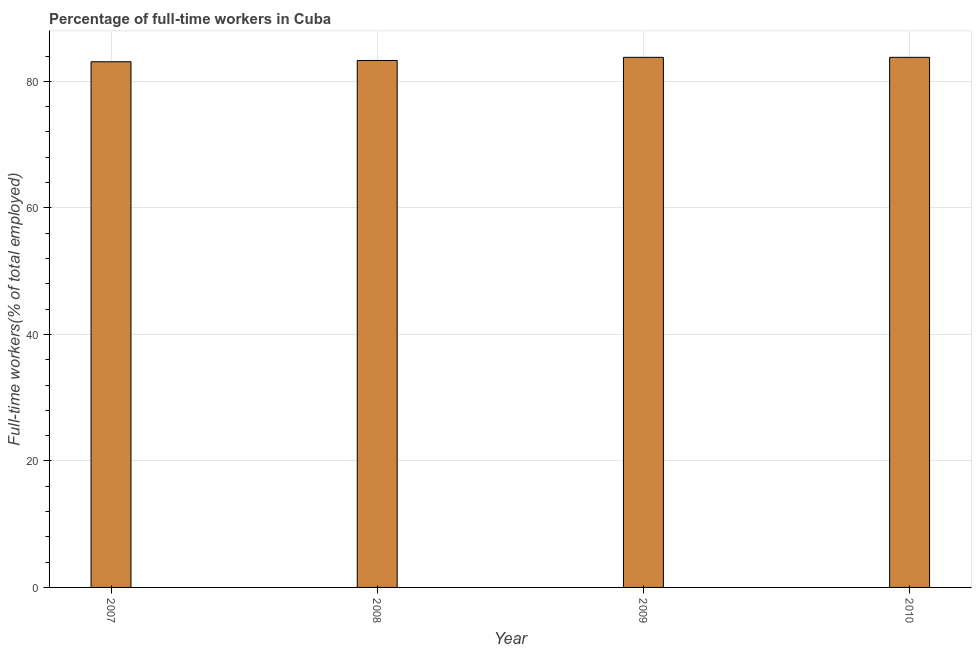Does the graph contain any zero values?
Your response must be concise. No. Does the graph contain grids?
Keep it short and to the point. Yes. What is the title of the graph?
Your answer should be very brief. Percentage of full-time workers in Cuba. What is the label or title of the Y-axis?
Your answer should be compact. Full-time workers(% of total employed). What is the percentage of full-time workers in 2009?
Offer a terse response. 83.8. Across all years, what is the maximum percentage of full-time workers?
Keep it short and to the point. 83.8. Across all years, what is the minimum percentage of full-time workers?
Keep it short and to the point. 83.1. What is the sum of the percentage of full-time workers?
Provide a succinct answer. 334. What is the average percentage of full-time workers per year?
Provide a succinct answer. 83.5. What is the median percentage of full-time workers?
Make the answer very short. 83.55. In how many years, is the percentage of full-time workers greater than 72 %?
Provide a succinct answer. 4. Do a majority of the years between 2007 and 2010 (inclusive) have percentage of full-time workers greater than 20 %?
Give a very brief answer. Yes. What is the ratio of the percentage of full-time workers in 2009 to that in 2010?
Your answer should be very brief. 1. What is the difference between the highest and the second highest percentage of full-time workers?
Your answer should be very brief. 0. In how many years, is the percentage of full-time workers greater than the average percentage of full-time workers taken over all years?
Provide a succinct answer. 2. How many bars are there?
Make the answer very short. 4. Are all the bars in the graph horizontal?
Provide a succinct answer. No. What is the difference between two consecutive major ticks on the Y-axis?
Ensure brevity in your answer.  20. What is the Full-time workers(% of total employed) of 2007?
Your answer should be very brief. 83.1. What is the Full-time workers(% of total employed) in 2008?
Ensure brevity in your answer.  83.3. What is the Full-time workers(% of total employed) of 2009?
Offer a terse response. 83.8. What is the Full-time workers(% of total employed) in 2010?
Your answer should be very brief. 83.8. What is the difference between the Full-time workers(% of total employed) in 2007 and 2009?
Make the answer very short. -0.7. What is the difference between the Full-time workers(% of total employed) in 2008 and 2010?
Give a very brief answer. -0.5. What is the ratio of the Full-time workers(% of total employed) in 2007 to that in 2009?
Provide a succinct answer. 0.99. What is the ratio of the Full-time workers(% of total employed) in 2007 to that in 2010?
Your response must be concise. 0.99. What is the ratio of the Full-time workers(% of total employed) in 2008 to that in 2010?
Your answer should be compact. 0.99. 